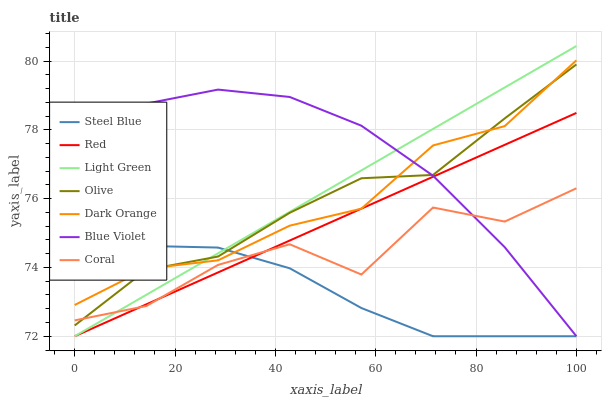Does Coral have the minimum area under the curve?
Answer yes or no. No. Does Coral have the maximum area under the curve?
Answer yes or no. No. Is Steel Blue the smoothest?
Answer yes or no. No. Is Steel Blue the roughest?
Answer yes or no. No. Does Coral have the lowest value?
Answer yes or no. No. Does Coral have the highest value?
Answer yes or no. No. Is Coral less than Dark Orange?
Answer yes or no. Yes. Is Dark Orange greater than Coral?
Answer yes or no. Yes. Does Coral intersect Dark Orange?
Answer yes or no. No. 